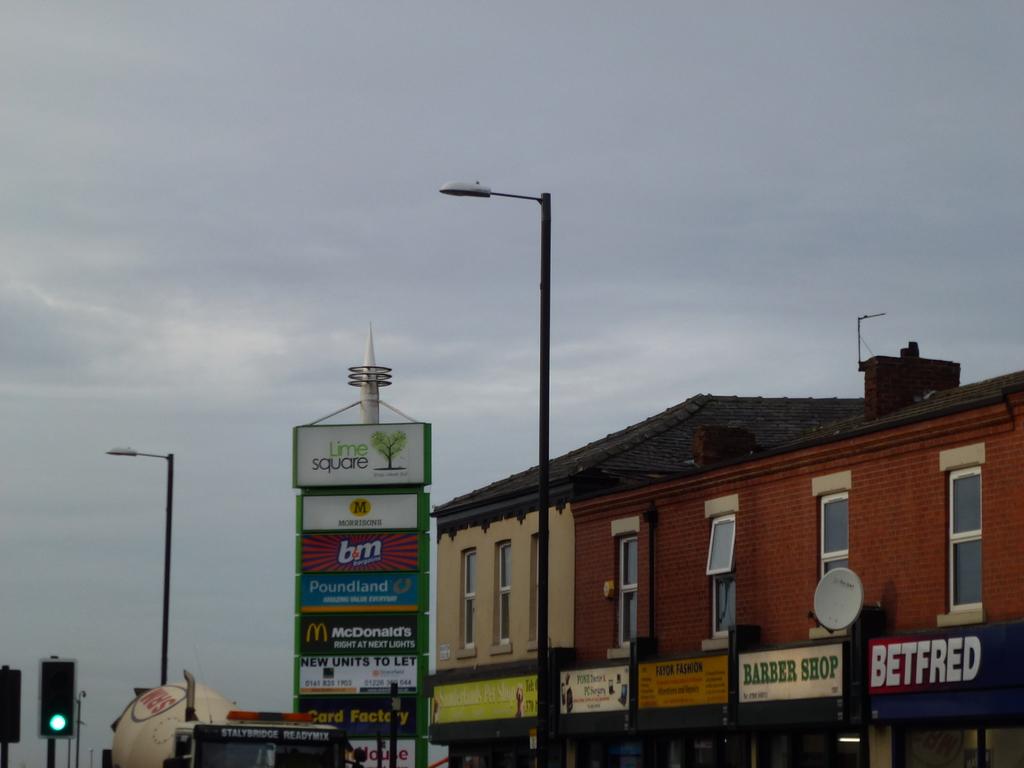What is the store with the blue sign called?
Your answer should be compact. Poundland. What type of shop has the white sign with green letters?
Ensure brevity in your answer.  Barber shop. 